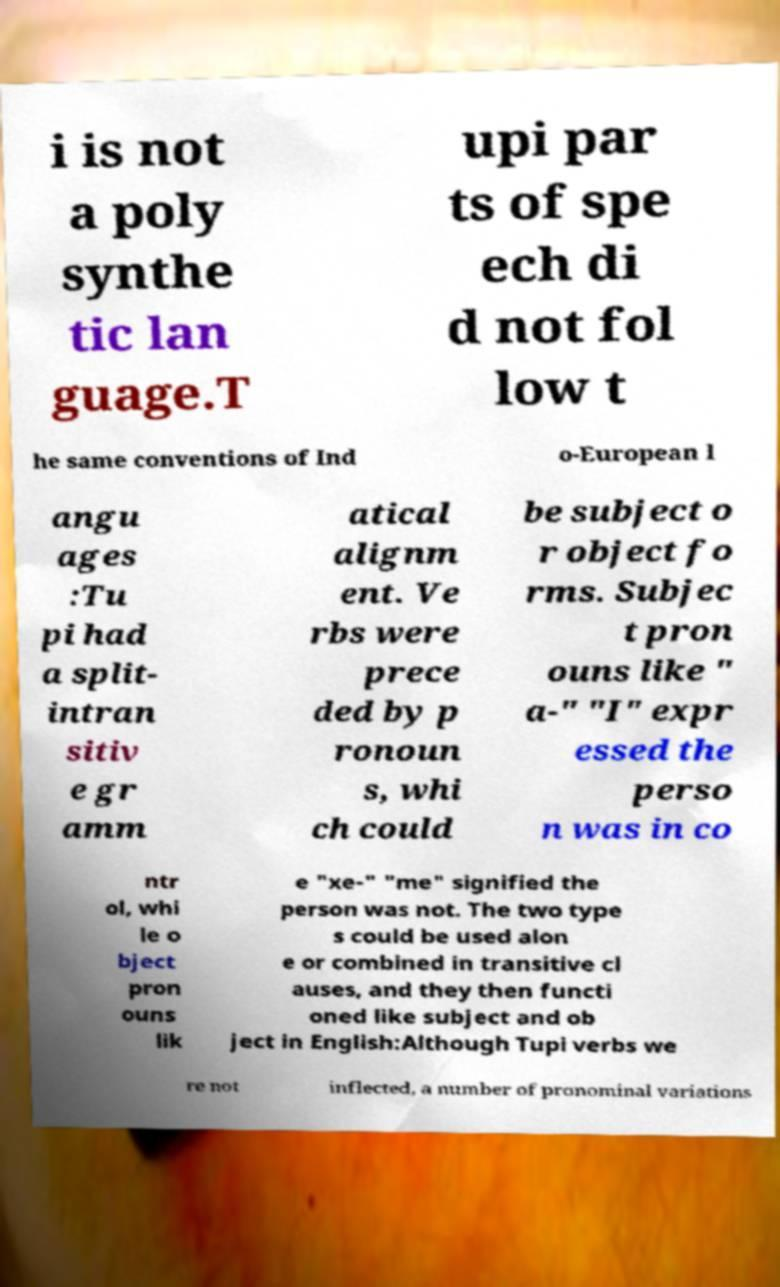Could you extract and type out the text from this image? i is not a poly synthe tic lan guage.T upi par ts of spe ech di d not fol low t he same conventions of Ind o-European l angu ages :Tu pi had a split- intran sitiv e gr amm atical alignm ent. Ve rbs were prece ded by p ronoun s, whi ch could be subject o r object fo rms. Subjec t pron ouns like " a-" "I" expr essed the perso n was in co ntr ol, whi le o bject pron ouns lik e "xe-" "me" signified the person was not. The two type s could be used alon e or combined in transitive cl auses, and they then functi oned like subject and ob ject in English:Although Tupi verbs we re not inflected, a number of pronominal variations 